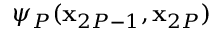<formula> <loc_0><loc_0><loc_500><loc_500>\psi _ { P } ( x _ { 2 P - 1 } , x _ { 2 P } )</formula> 